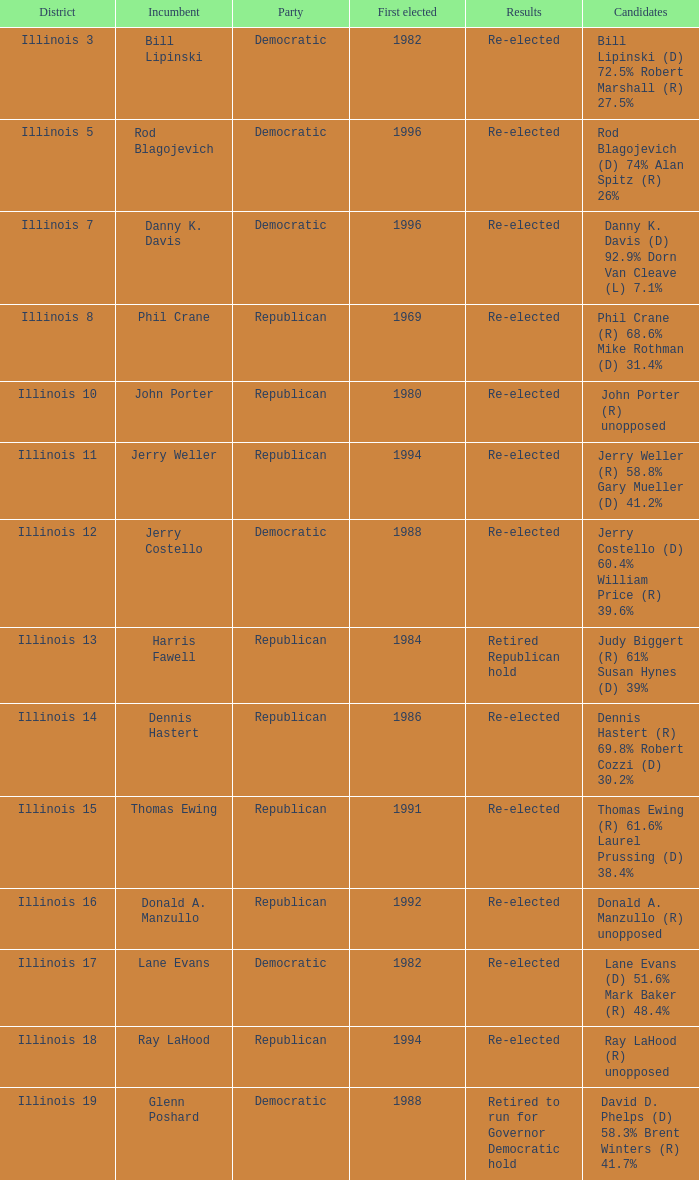What area did john porter get elected in? Illinois 10. 